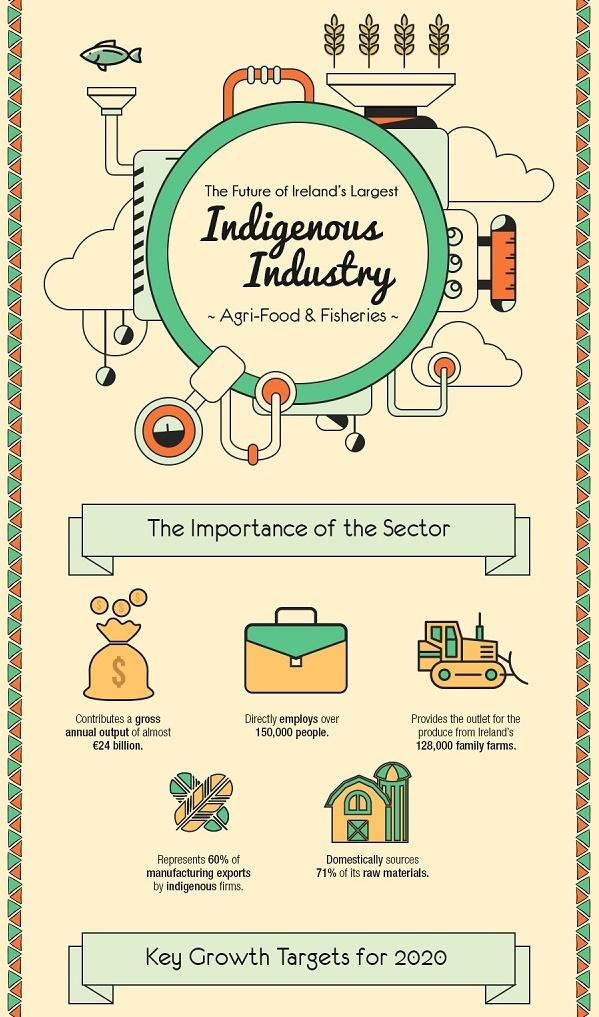Identify some key points in this picture. Approximately 128,000 family farms rely on the agri-food and fisheries sector for their livelihood. The color of the fish is green, and not yellow. In the indigenous industry, approximately 150,000 people are employed. The majority of raw materials are sourced domestically. 